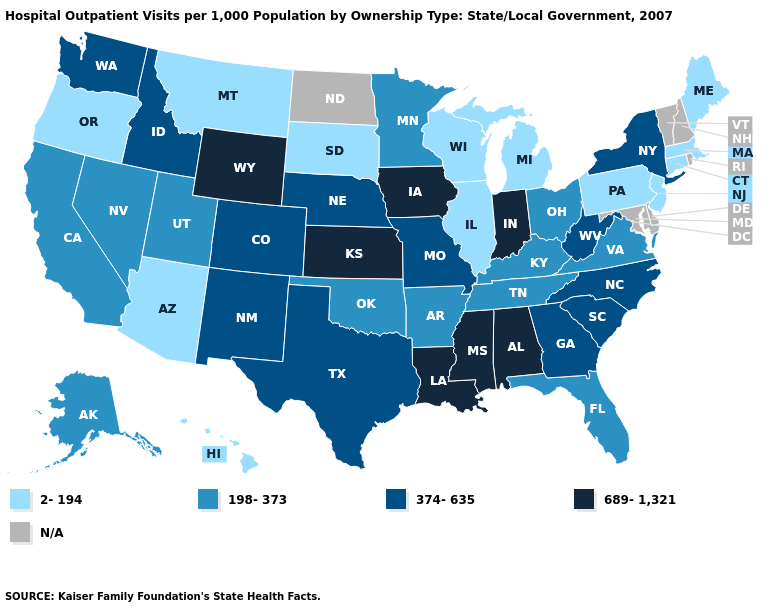Name the states that have a value in the range 198-373?
Answer briefly. Alaska, Arkansas, California, Florida, Kentucky, Minnesota, Nevada, Ohio, Oklahoma, Tennessee, Utah, Virginia. How many symbols are there in the legend?
Answer briefly. 5. How many symbols are there in the legend?
Be succinct. 5. What is the value of Indiana?
Quick response, please. 689-1,321. What is the value of Arizona?
Answer briefly. 2-194. Name the states that have a value in the range 689-1,321?
Give a very brief answer. Alabama, Indiana, Iowa, Kansas, Louisiana, Mississippi, Wyoming. Name the states that have a value in the range 689-1,321?
Keep it brief. Alabama, Indiana, Iowa, Kansas, Louisiana, Mississippi, Wyoming. What is the lowest value in states that border Kentucky?
Give a very brief answer. 2-194. Is the legend a continuous bar?
Quick response, please. No. What is the value of Maryland?
Give a very brief answer. N/A. Which states have the lowest value in the USA?
Write a very short answer. Arizona, Connecticut, Hawaii, Illinois, Maine, Massachusetts, Michigan, Montana, New Jersey, Oregon, Pennsylvania, South Dakota, Wisconsin. Among the states that border Wisconsin , which have the highest value?
Keep it brief. Iowa. What is the lowest value in the USA?
Quick response, please. 2-194. What is the value of Mississippi?
Quick response, please. 689-1,321. How many symbols are there in the legend?
Short answer required. 5. 